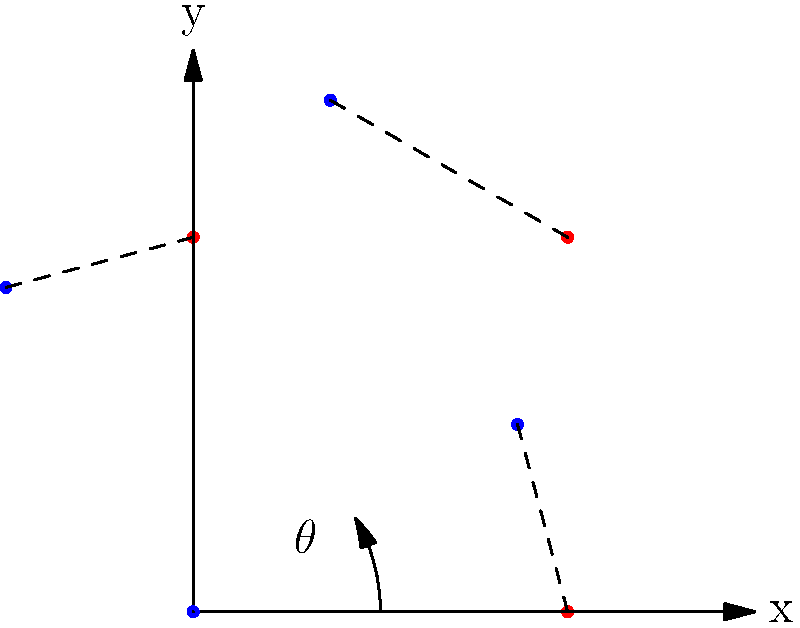A square crystal lattice is rotated counterclockwise by an angle $\theta = 30°$ (or $\pi/6$ radians) about the origin. Given the rotation matrix $R(\theta) = \begin{pmatrix} \cos\theta & -\sin\theta \\ \sin\theta & \cos\theta \end{pmatrix}$, calculate the new coordinates of the lattice point originally at $(1,1)$ after the rotation. Round your answer to three decimal places. To solve this problem, we'll follow these steps:

1) The rotation matrix $R(\theta)$ for a counterclockwise rotation by angle $\theta$ is given as:

   $R(\theta) = \begin{pmatrix} \cos\theta & -\sin\theta \\ \sin\theta & \cos\theta \end{pmatrix}$

2) We're given $\theta = 30° = \pi/6$ radians. Let's calculate the sine and cosine:

   $\cos(\pi/6) = \frac{\sqrt{3}}{2} \approx 0.866$
   $\sin(\pi/6) = \frac{1}{2} = 0.5$

3) Substituting these values into the rotation matrix:

   $R(\pi/6) = \begin{pmatrix} 0.866 & -0.5 \\ 0.5 & 0.866 \end{pmatrix}$

4) The original point is $(1,1)$. To find its new position, we multiply the rotation matrix by the column vector of the point:

   $\begin{pmatrix} x' \\ y' \end{pmatrix} = \begin{pmatrix} 0.866 & -0.5 \\ 0.5 & 0.866 \end{pmatrix} \begin{pmatrix} 1 \\ 1 \end{pmatrix}$

5) Performing the matrix multiplication:

   $x' = 0.866 \cdot 1 + (-0.5) \cdot 1 = 0.866 - 0.5 = 0.366$
   $y' = 0.5 \cdot 1 + 0.866 \cdot 1 = 0.5 + 0.866 = 1.366$

6) Rounding to three decimal places:

   $x' \approx 0.366$
   $y' \approx 1.366$

Therefore, the new coordinates of the point $(1,1)$ after rotation are approximately $(0.366, 1.366)$.
Answer: $(0.366, 1.366)$ 